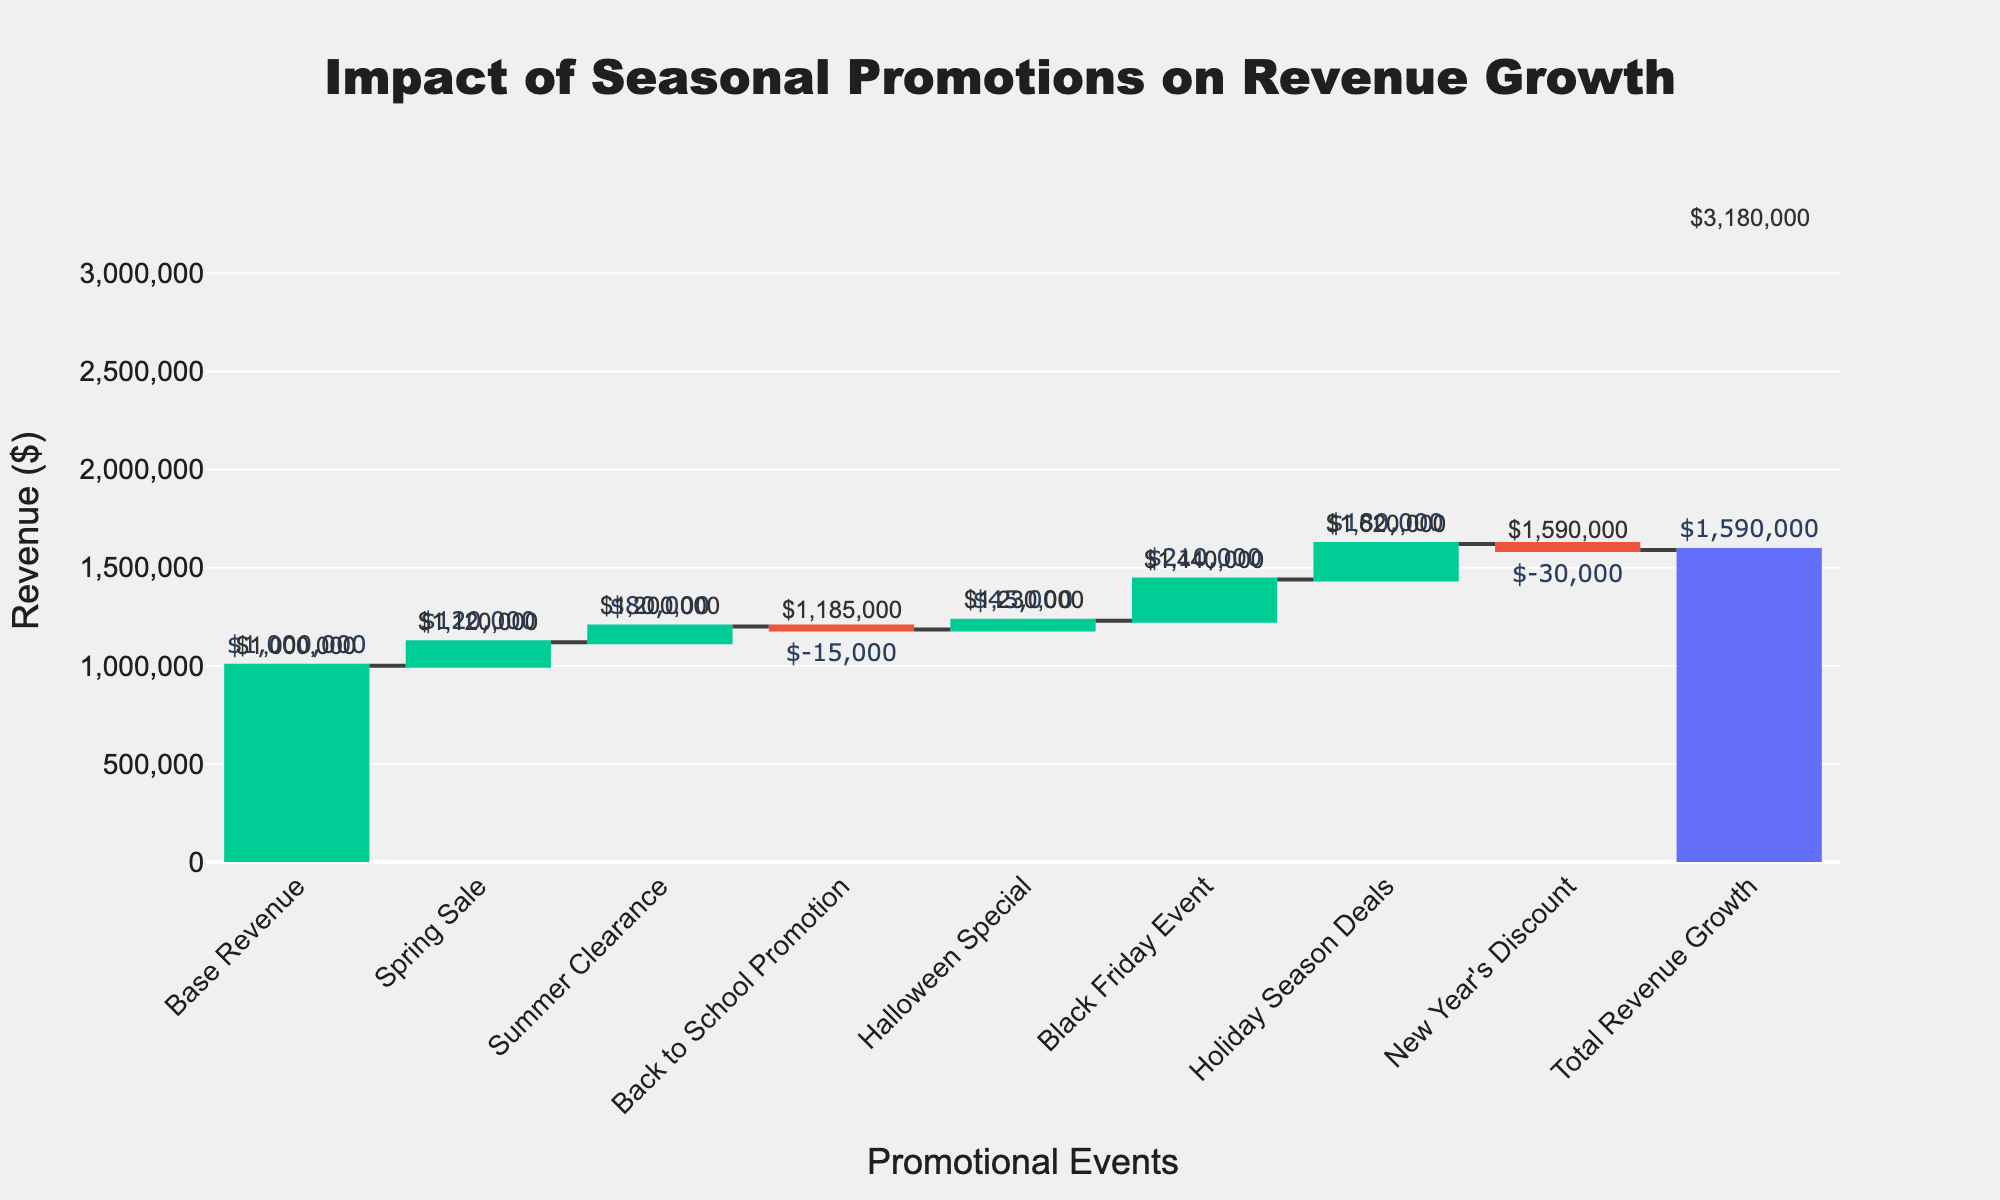What's the title of the figure? The title of the figure is prominently displayed at the top center of the chart. It reads "Impact of Seasonal Promotions on Revenue Growth".
Answer: Impact of Seasonal Promotions on Revenue Growth Which promotional event had the most significant positive impact on revenue? By examining the heights of the bars, we see that the "Black Friday Event" has the tallest green bar, indicating it had the highest positive value among the promotions.
Answer: Black Friday Event How much revenue did the Spring Sale contribute? The bar for "Spring Sale" shows its value, which is marked with a text label "$120,000".
Answer: $120,000 What is the final total revenue after applying all promotions? The last bar, which is darker in color and marked as "Total Revenue Growth," shows the final revenue value with the label "$1,590,000".
Answer: $1,590,000 Which promotional events had a negative impact on revenue? Negative contributions are shown with red bars. The bars for "Back to School Promotion" ($-15,000) and "New Year's Discount" ($-30,000) are red, indicating negative impacts.
Answer: Back to School Promotion, New Year's Discount What is the cumulative revenue after the Halloween Special? The cumulative revenue after the Halloween Special can be found by adding up the values from "Base Revenue" ($1,000,000), "Spring Sale" ($120,000), "Summer Clearance" ($80,000), and "Back to School Promotion" (-$15,000). The cumulative value, displayed as a small number next to the result of these additions, is $1,185,000.
Answer: $1,185,000 By how much does the Black Friday Event increase the cumulative revenue? Before the Black Friday Event, the cumulative revenue includes the contributions from all previous events. Calculate the value before Black Friday (up to Halloween Special) and add the Black Friday Event's impact ($210,000). The cumulative value jumps from $1,230,000 to $1,440,000, indicating an increase of $210,000.
Answer: $210,000 What is the net impact of all the events with a negative contribution on the total revenue? The net impact of negative events involves summing the negative contributions: "Back to School Promotion" ($-15,000) and "New Year's Discount" ($-30,000). Adding them together gives a net negative impact of $-45,000.
Answer: $-45,000 How does the revenue after the Holiday Season Deals compare to the revenue after the Summer Clearance? After the Summer Clearance, the cumulative revenue is marked at $1,185,000. Post-Holiday Season Deals, the cumulative value is shown at $1,620,000. The difference in cumulative revenue between these two points is $1,620,000 - $1,185,000 = $435,000.
Answer: $435,000 